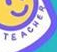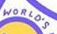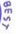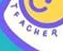Read the text from these images in sequence, separated by a semicolon. TEACHER; WORLO'S; BEST; TEACHER 